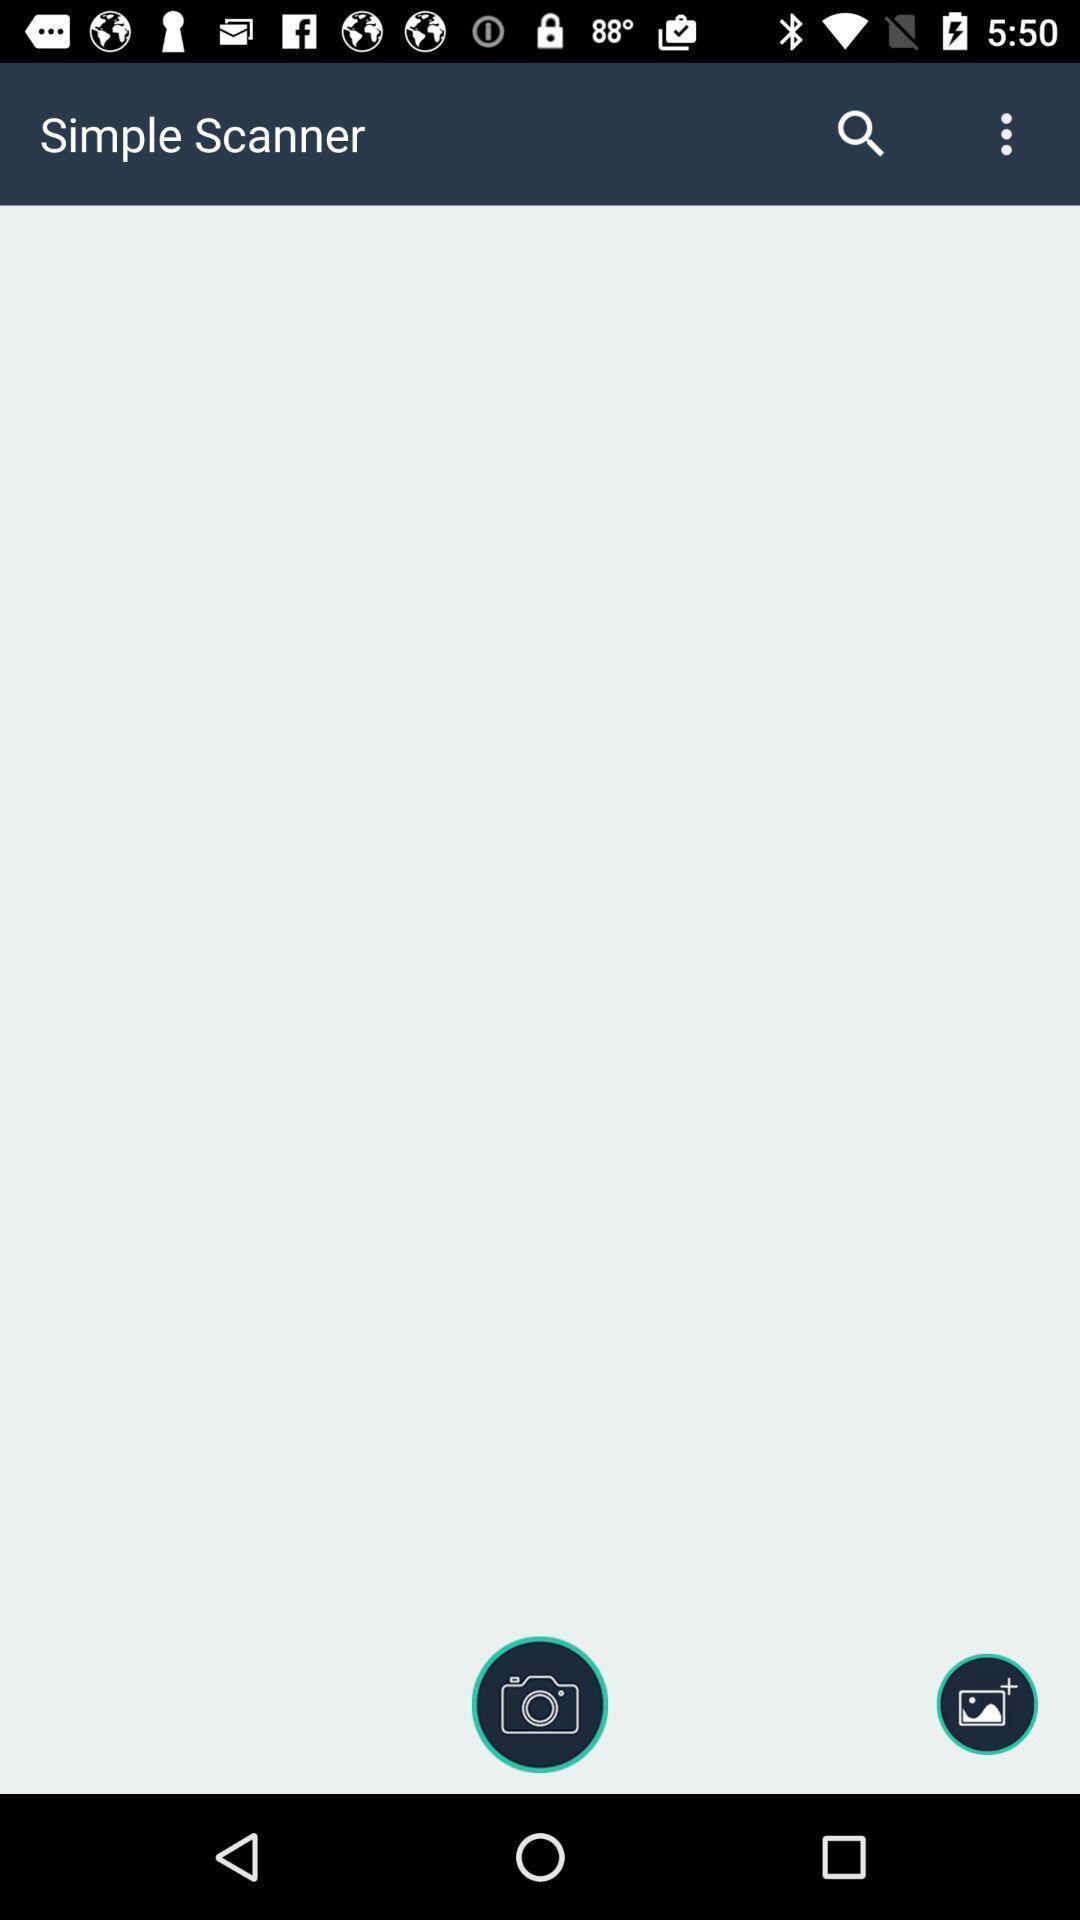Describe this image in words. Screen shows a simple scanner. 